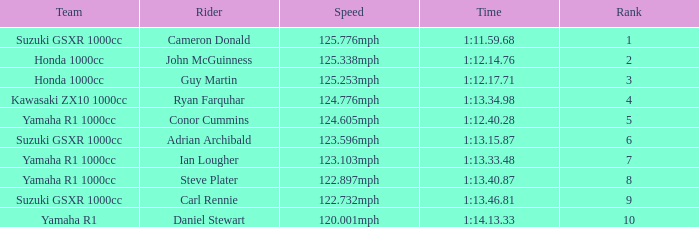What is the rank for the team with a Time of 1:12.40.28? 5.0. 